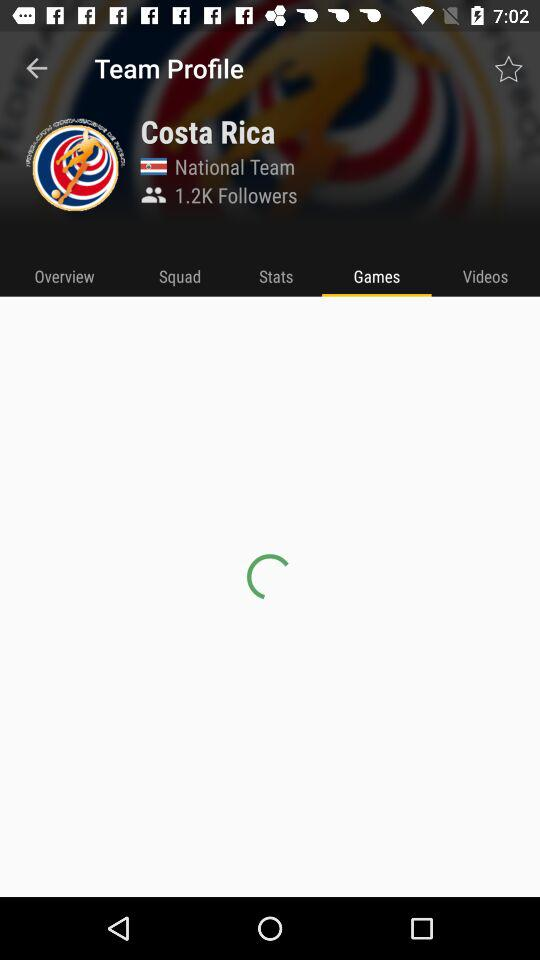How many followers are there? There are 1.2K followers. 